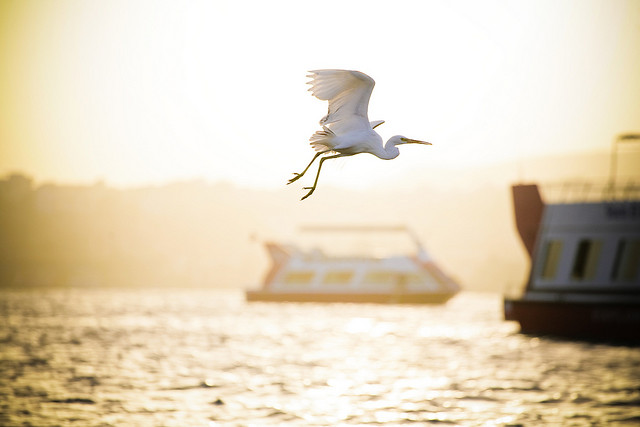Imagine you are the bird in the image. What would be your thoughts or feelings in this moment? As the bird in the image, I would feel a sense of freedom and exhilaration as I glide effortlessly through the air, with the wind beneath my wings and the golden light of the setting sun surrounding me. The vast open sky and tranquil waterway below create a perfect harmony, allowing me to feel at peace and deeply connected to the beauty of nature. 